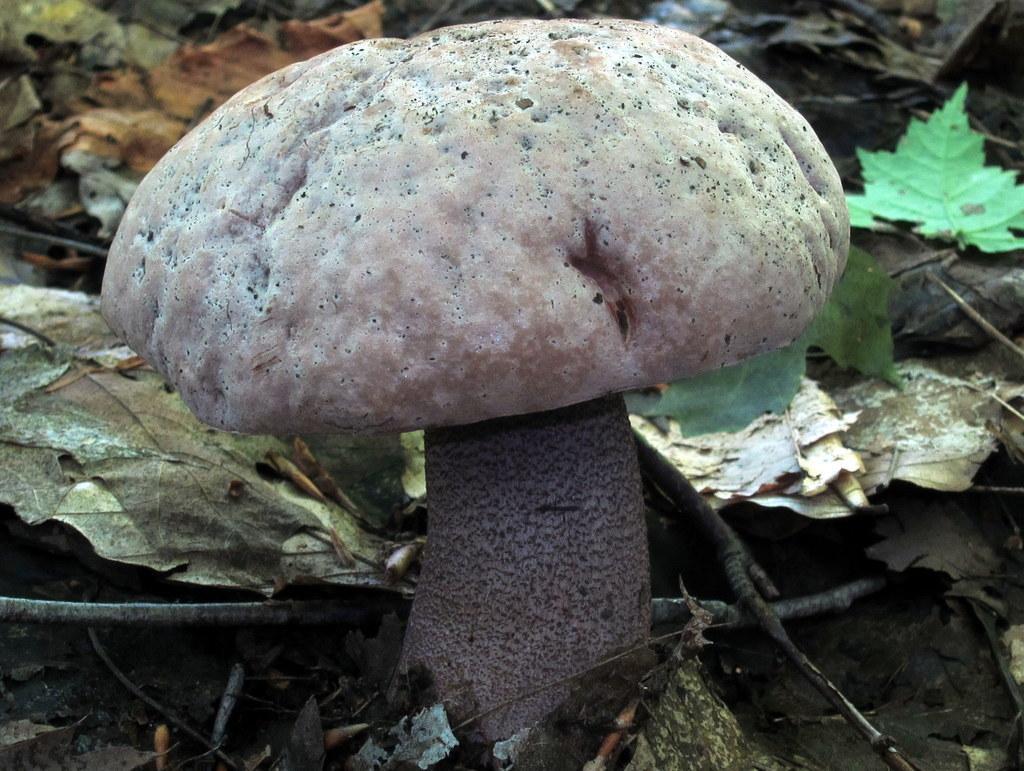In one or two sentences, can you explain what this image depicts? In the center of the image we can see a mushroom. In the background, we can see leaves and twigs. 